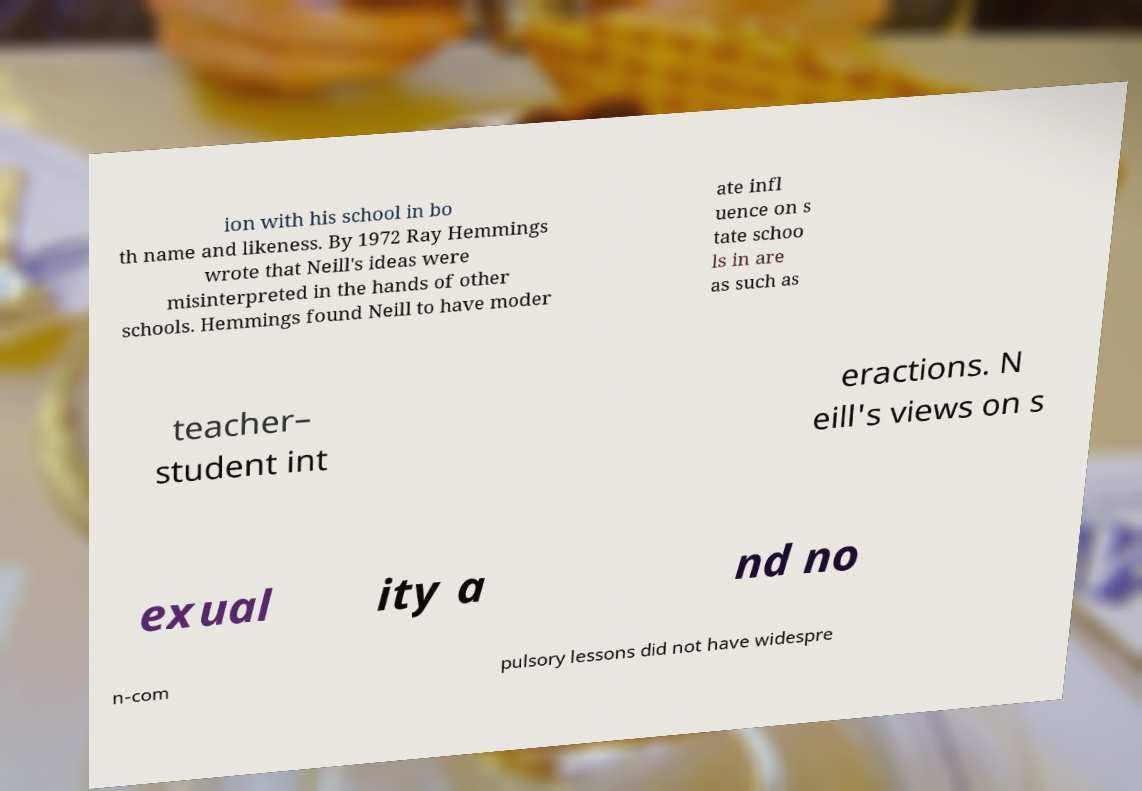I need the written content from this picture converted into text. Can you do that? ion with his school in bo th name and likeness. By 1972 Ray Hemmings wrote that Neill's ideas were misinterpreted in the hands of other schools. Hemmings found Neill to have moder ate infl uence on s tate schoo ls in are as such as teacher– student int eractions. N eill's views on s exual ity a nd no n-com pulsory lessons did not have widespre 